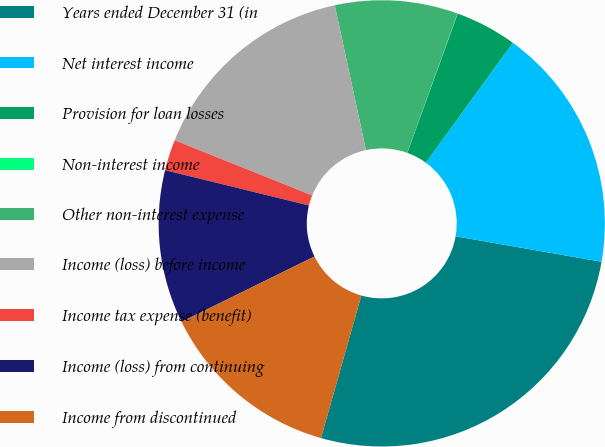Convert chart. <chart><loc_0><loc_0><loc_500><loc_500><pie_chart><fcel>Years ended December 31 (in<fcel>Net interest income<fcel>Provision for loan losses<fcel>Non-interest income<fcel>Other non-interest expense<fcel>Income (loss) before income<fcel>Income tax expense (benefit)<fcel>Income (loss) from continuing<fcel>Income from discontinued<nl><fcel>26.64%<fcel>17.76%<fcel>4.46%<fcel>0.02%<fcel>8.89%<fcel>15.55%<fcel>2.24%<fcel>11.11%<fcel>13.33%<nl></chart> 